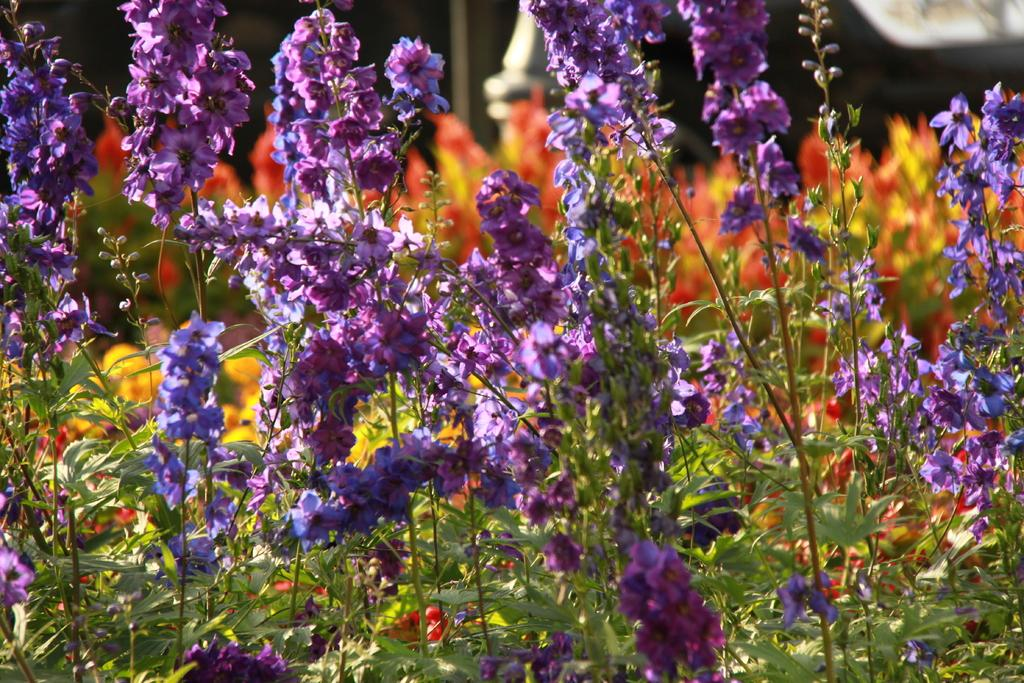What type of plants are in the image? There are flower plants in the image. What color are the flowers on the plants? The flowers on the plants are purple. How is the background of the plants depicted in the image? The background of the plants is blurred. What type of pen can be seen in the image? There is no pen present in the image; it features flower plants with purple flowers and a blurred background. 